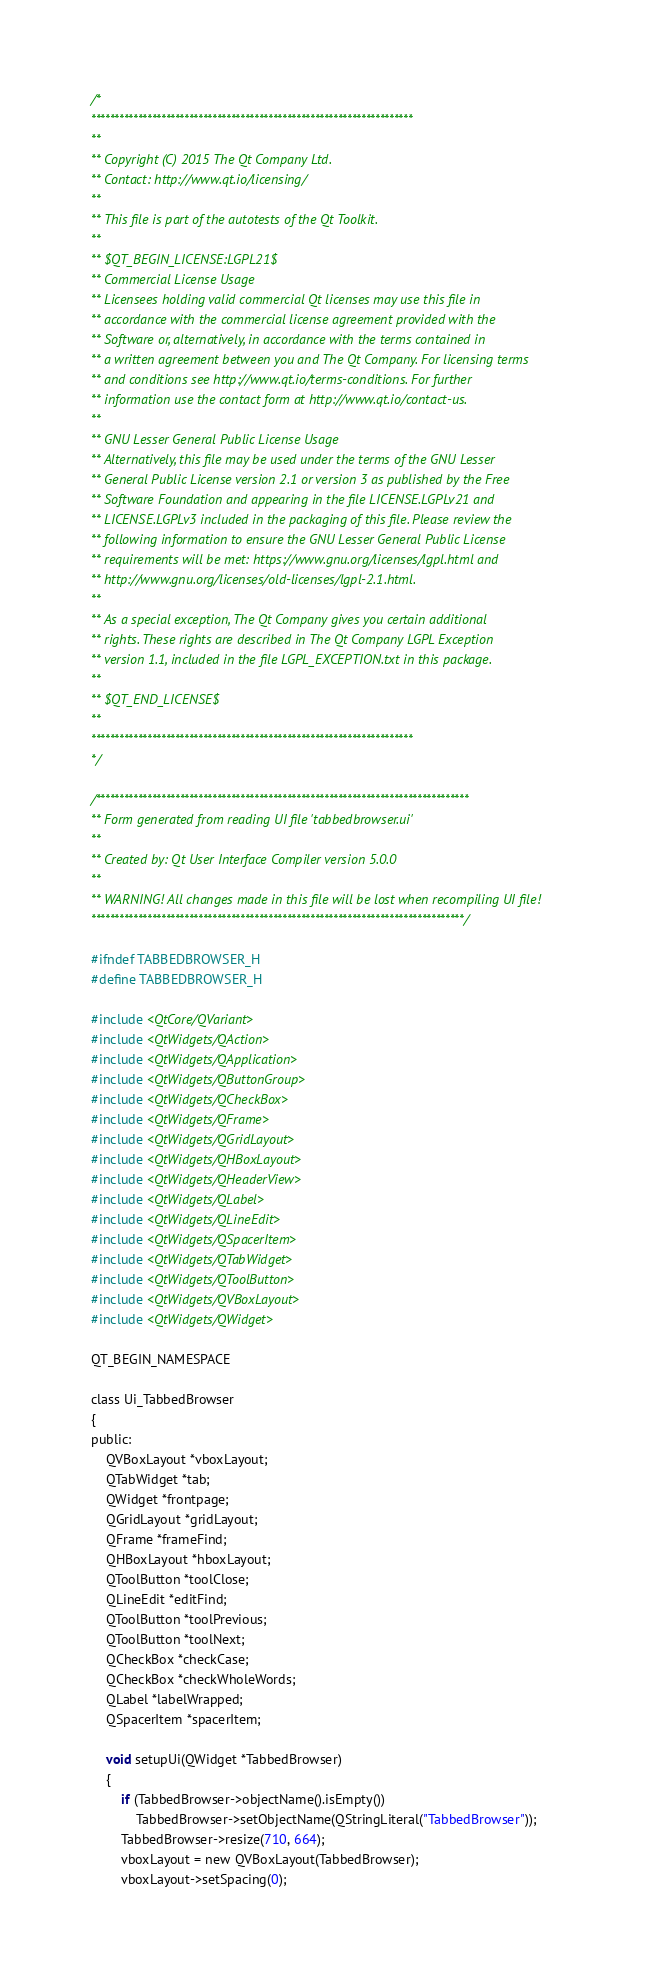Convert code to text. <code><loc_0><loc_0><loc_500><loc_500><_C_>/*
*********************************************************************
**
** Copyright (C) 2015 The Qt Company Ltd.
** Contact: http://www.qt.io/licensing/
**
** This file is part of the autotests of the Qt Toolkit.
**
** $QT_BEGIN_LICENSE:LGPL21$
** Commercial License Usage
** Licensees holding valid commercial Qt licenses may use this file in
** accordance with the commercial license agreement provided with the
** Software or, alternatively, in accordance with the terms contained in
** a written agreement between you and The Qt Company. For licensing terms
** and conditions see http://www.qt.io/terms-conditions. For further
** information use the contact form at http://www.qt.io/contact-us.
**
** GNU Lesser General Public License Usage
** Alternatively, this file may be used under the terms of the GNU Lesser
** General Public License version 2.1 or version 3 as published by the Free
** Software Foundation and appearing in the file LICENSE.LGPLv21 and
** LICENSE.LGPLv3 included in the packaging of this file. Please review the
** following information to ensure the GNU Lesser General Public License
** requirements will be met: https://www.gnu.org/licenses/lgpl.html and
** http://www.gnu.org/licenses/old-licenses/lgpl-2.1.html.
**
** As a special exception, The Qt Company gives you certain additional
** rights. These rights are described in The Qt Company LGPL Exception
** version 1.1, included in the file LGPL_EXCEPTION.txt in this package.
**
** $QT_END_LICENSE$
**
*********************************************************************
*/

/********************************************************************************
** Form generated from reading UI file 'tabbedbrowser.ui'
**
** Created by: Qt User Interface Compiler version 5.0.0
**
** WARNING! All changes made in this file will be lost when recompiling UI file!
********************************************************************************/

#ifndef TABBEDBROWSER_H
#define TABBEDBROWSER_H

#include <QtCore/QVariant>
#include <QtWidgets/QAction>
#include <QtWidgets/QApplication>
#include <QtWidgets/QButtonGroup>
#include <QtWidgets/QCheckBox>
#include <QtWidgets/QFrame>
#include <QtWidgets/QGridLayout>
#include <QtWidgets/QHBoxLayout>
#include <QtWidgets/QHeaderView>
#include <QtWidgets/QLabel>
#include <QtWidgets/QLineEdit>
#include <QtWidgets/QSpacerItem>
#include <QtWidgets/QTabWidget>
#include <QtWidgets/QToolButton>
#include <QtWidgets/QVBoxLayout>
#include <QtWidgets/QWidget>

QT_BEGIN_NAMESPACE

class Ui_TabbedBrowser
{
public:
    QVBoxLayout *vboxLayout;
    QTabWidget *tab;
    QWidget *frontpage;
    QGridLayout *gridLayout;
    QFrame *frameFind;
    QHBoxLayout *hboxLayout;
    QToolButton *toolClose;
    QLineEdit *editFind;
    QToolButton *toolPrevious;
    QToolButton *toolNext;
    QCheckBox *checkCase;
    QCheckBox *checkWholeWords;
    QLabel *labelWrapped;
    QSpacerItem *spacerItem;

    void setupUi(QWidget *TabbedBrowser)
    {
        if (TabbedBrowser->objectName().isEmpty())
            TabbedBrowser->setObjectName(QStringLiteral("TabbedBrowser"));
        TabbedBrowser->resize(710, 664);
        vboxLayout = new QVBoxLayout(TabbedBrowser);
        vboxLayout->setSpacing(0);</code> 